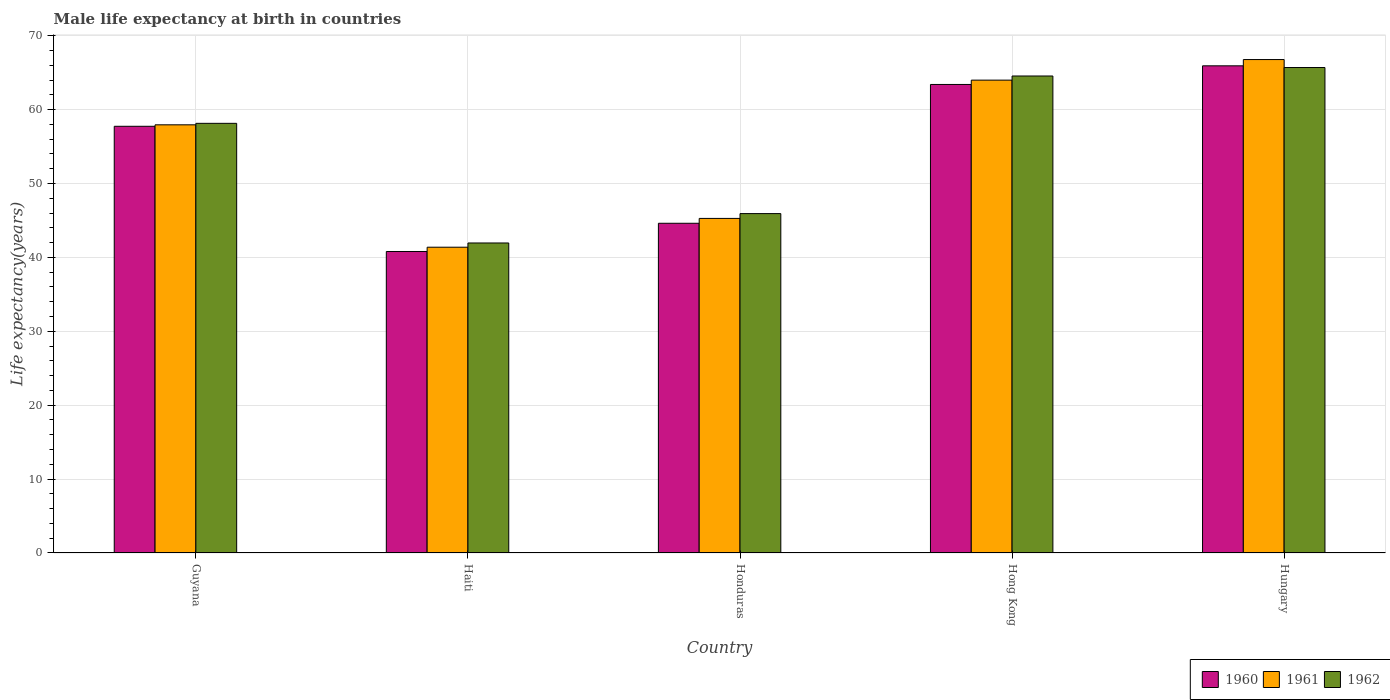How many groups of bars are there?
Your response must be concise. 5. Are the number of bars on each tick of the X-axis equal?
Offer a terse response. Yes. How many bars are there on the 5th tick from the left?
Provide a succinct answer. 3. What is the label of the 3rd group of bars from the left?
Ensure brevity in your answer.  Honduras. In how many cases, is the number of bars for a given country not equal to the number of legend labels?
Give a very brief answer. 0. What is the male life expectancy at birth in 1962 in Hong Kong?
Ensure brevity in your answer.  64.55. Across all countries, what is the maximum male life expectancy at birth in 1961?
Offer a very short reply. 66.78. Across all countries, what is the minimum male life expectancy at birth in 1961?
Your answer should be compact. 41.38. In which country was the male life expectancy at birth in 1960 maximum?
Keep it short and to the point. Hungary. In which country was the male life expectancy at birth in 1962 minimum?
Make the answer very short. Haiti. What is the total male life expectancy at birth in 1960 in the graph?
Offer a terse response. 272.51. What is the difference between the male life expectancy at birth in 1961 in Guyana and that in Haiti?
Give a very brief answer. 16.56. What is the difference between the male life expectancy at birth in 1960 in Hungary and the male life expectancy at birth in 1961 in Guyana?
Your answer should be compact. 7.98. What is the average male life expectancy at birth in 1960 per country?
Offer a very short reply. 54.5. What is the difference between the male life expectancy at birth of/in 1961 and male life expectancy at birth of/in 1960 in Hungary?
Provide a short and direct response. 0.85. In how many countries, is the male life expectancy at birth in 1961 greater than 38 years?
Your response must be concise. 5. What is the ratio of the male life expectancy at birth in 1962 in Guyana to that in Haiti?
Provide a short and direct response. 1.39. Is the male life expectancy at birth in 1962 in Guyana less than that in Hong Kong?
Keep it short and to the point. Yes. What is the difference between the highest and the second highest male life expectancy at birth in 1960?
Ensure brevity in your answer.  8.18. What is the difference between the highest and the lowest male life expectancy at birth in 1961?
Keep it short and to the point. 25.4. Is the sum of the male life expectancy at birth in 1960 in Haiti and Hong Kong greater than the maximum male life expectancy at birth in 1962 across all countries?
Offer a terse response. Yes. What does the 2nd bar from the left in Haiti represents?
Your answer should be very brief. 1961. What does the 1st bar from the right in Hong Kong represents?
Give a very brief answer. 1962. Is it the case that in every country, the sum of the male life expectancy at birth in 1961 and male life expectancy at birth in 1960 is greater than the male life expectancy at birth in 1962?
Offer a terse response. Yes. Are all the bars in the graph horizontal?
Provide a succinct answer. No. How many countries are there in the graph?
Provide a short and direct response. 5. What is the difference between two consecutive major ticks on the Y-axis?
Keep it short and to the point. 10. Are the values on the major ticks of Y-axis written in scientific E-notation?
Provide a succinct answer. No. How many legend labels are there?
Keep it short and to the point. 3. How are the legend labels stacked?
Keep it short and to the point. Horizontal. What is the title of the graph?
Make the answer very short. Male life expectancy at birth in countries. What is the label or title of the X-axis?
Provide a short and direct response. Country. What is the label or title of the Y-axis?
Ensure brevity in your answer.  Life expectancy(years). What is the Life expectancy(years) in 1960 in Guyana?
Ensure brevity in your answer.  57.75. What is the Life expectancy(years) of 1961 in Guyana?
Make the answer very short. 57.95. What is the Life expectancy(years) in 1962 in Guyana?
Give a very brief answer. 58.15. What is the Life expectancy(years) of 1960 in Haiti?
Offer a very short reply. 40.8. What is the Life expectancy(years) of 1961 in Haiti?
Give a very brief answer. 41.38. What is the Life expectancy(years) in 1962 in Haiti?
Your answer should be very brief. 41.96. What is the Life expectancy(years) of 1960 in Honduras?
Provide a short and direct response. 44.62. What is the Life expectancy(years) in 1961 in Honduras?
Your response must be concise. 45.28. What is the Life expectancy(years) in 1962 in Honduras?
Ensure brevity in your answer.  45.93. What is the Life expectancy(years) in 1960 in Hong Kong?
Your response must be concise. 63.41. What is the Life expectancy(years) in 1961 in Hong Kong?
Your answer should be very brief. 63.99. What is the Life expectancy(years) in 1962 in Hong Kong?
Ensure brevity in your answer.  64.55. What is the Life expectancy(years) in 1960 in Hungary?
Your answer should be compact. 65.93. What is the Life expectancy(years) of 1961 in Hungary?
Your response must be concise. 66.78. What is the Life expectancy(years) of 1962 in Hungary?
Your response must be concise. 65.7. Across all countries, what is the maximum Life expectancy(years) in 1960?
Give a very brief answer. 65.93. Across all countries, what is the maximum Life expectancy(years) of 1961?
Keep it short and to the point. 66.78. Across all countries, what is the maximum Life expectancy(years) of 1962?
Keep it short and to the point. 65.7. Across all countries, what is the minimum Life expectancy(years) of 1960?
Provide a short and direct response. 40.8. Across all countries, what is the minimum Life expectancy(years) in 1961?
Ensure brevity in your answer.  41.38. Across all countries, what is the minimum Life expectancy(years) in 1962?
Keep it short and to the point. 41.96. What is the total Life expectancy(years) in 1960 in the graph?
Offer a terse response. 272.51. What is the total Life expectancy(years) of 1961 in the graph?
Keep it short and to the point. 275.38. What is the total Life expectancy(years) in 1962 in the graph?
Make the answer very short. 276.29. What is the difference between the Life expectancy(years) in 1960 in Guyana and that in Haiti?
Provide a short and direct response. 16.94. What is the difference between the Life expectancy(years) of 1961 in Guyana and that in Haiti?
Your answer should be compact. 16.56. What is the difference between the Life expectancy(years) in 1962 in Guyana and that in Haiti?
Ensure brevity in your answer.  16.19. What is the difference between the Life expectancy(years) of 1960 in Guyana and that in Honduras?
Your answer should be very brief. 13.13. What is the difference between the Life expectancy(years) in 1961 in Guyana and that in Honduras?
Ensure brevity in your answer.  12.67. What is the difference between the Life expectancy(years) of 1962 in Guyana and that in Honduras?
Provide a succinct answer. 12.22. What is the difference between the Life expectancy(years) in 1960 in Guyana and that in Hong Kong?
Your answer should be very brief. -5.66. What is the difference between the Life expectancy(years) of 1961 in Guyana and that in Hong Kong?
Your answer should be very brief. -6.05. What is the difference between the Life expectancy(years) of 1962 in Guyana and that in Hong Kong?
Your answer should be compact. -6.41. What is the difference between the Life expectancy(years) of 1960 in Guyana and that in Hungary?
Make the answer very short. -8.18. What is the difference between the Life expectancy(years) of 1961 in Guyana and that in Hungary?
Keep it short and to the point. -8.83. What is the difference between the Life expectancy(years) of 1962 in Guyana and that in Hungary?
Ensure brevity in your answer.  -7.55. What is the difference between the Life expectancy(years) in 1960 in Haiti and that in Honduras?
Provide a succinct answer. -3.82. What is the difference between the Life expectancy(years) of 1961 in Haiti and that in Honduras?
Your response must be concise. -3.9. What is the difference between the Life expectancy(years) of 1962 in Haiti and that in Honduras?
Offer a terse response. -3.98. What is the difference between the Life expectancy(years) of 1960 in Haiti and that in Hong Kong?
Ensure brevity in your answer.  -22.6. What is the difference between the Life expectancy(years) of 1961 in Haiti and that in Hong Kong?
Give a very brief answer. -22.61. What is the difference between the Life expectancy(years) in 1962 in Haiti and that in Hong Kong?
Offer a terse response. -22.6. What is the difference between the Life expectancy(years) in 1960 in Haiti and that in Hungary?
Offer a terse response. -25.13. What is the difference between the Life expectancy(years) of 1961 in Haiti and that in Hungary?
Offer a very short reply. -25.4. What is the difference between the Life expectancy(years) of 1962 in Haiti and that in Hungary?
Provide a short and direct response. -23.74. What is the difference between the Life expectancy(years) of 1960 in Honduras and that in Hong Kong?
Your response must be concise. -18.79. What is the difference between the Life expectancy(years) in 1961 in Honduras and that in Hong Kong?
Offer a very short reply. -18.71. What is the difference between the Life expectancy(years) in 1962 in Honduras and that in Hong Kong?
Give a very brief answer. -18.62. What is the difference between the Life expectancy(years) of 1960 in Honduras and that in Hungary?
Give a very brief answer. -21.31. What is the difference between the Life expectancy(years) of 1961 in Honduras and that in Hungary?
Keep it short and to the point. -21.5. What is the difference between the Life expectancy(years) of 1962 in Honduras and that in Hungary?
Offer a very short reply. -19.77. What is the difference between the Life expectancy(years) in 1960 in Hong Kong and that in Hungary?
Offer a terse response. -2.52. What is the difference between the Life expectancy(years) in 1961 in Hong Kong and that in Hungary?
Your response must be concise. -2.79. What is the difference between the Life expectancy(years) of 1962 in Hong Kong and that in Hungary?
Make the answer very short. -1.15. What is the difference between the Life expectancy(years) of 1960 in Guyana and the Life expectancy(years) of 1961 in Haiti?
Your answer should be very brief. 16.37. What is the difference between the Life expectancy(years) in 1960 in Guyana and the Life expectancy(years) in 1962 in Haiti?
Ensure brevity in your answer.  15.79. What is the difference between the Life expectancy(years) of 1961 in Guyana and the Life expectancy(years) of 1962 in Haiti?
Make the answer very short. 15.99. What is the difference between the Life expectancy(years) of 1960 in Guyana and the Life expectancy(years) of 1961 in Honduras?
Give a very brief answer. 12.47. What is the difference between the Life expectancy(years) in 1960 in Guyana and the Life expectancy(years) in 1962 in Honduras?
Keep it short and to the point. 11.82. What is the difference between the Life expectancy(years) in 1961 in Guyana and the Life expectancy(years) in 1962 in Honduras?
Provide a short and direct response. 12.02. What is the difference between the Life expectancy(years) of 1960 in Guyana and the Life expectancy(years) of 1961 in Hong Kong?
Make the answer very short. -6.25. What is the difference between the Life expectancy(years) in 1960 in Guyana and the Life expectancy(years) in 1962 in Hong Kong?
Ensure brevity in your answer.  -6.81. What is the difference between the Life expectancy(years) of 1961 in Guyana and the Life expectancy(years) of 1962 in Hong Kong?
Provide a short and direct response. -6.61. What is the difference between the Life expectancy(years) in 1960 in Guyana and the Life expectancy(years) in 1961 in Hungary?
Keep it short and to the point. -9.03. What is the difference between the Life expectancy(years) in 1960 in Guyana and the Life expectancy(years) in 1962 in Hungary?
Provide a short and direct response. -7.95. What is the difference between the Life expectancy(years) in 1961 in Guyana and the Life expectancy(years) in 1962 in Hungary?
Make the answer very short. -7.75. What is the difference between the Life expectancy(years) of 1960 in Haiti and the Life expectancy(years) of 1961 in Honduras?
Give a very brief answer. -4.47. What is the difference between the Life expectancy(years) in 1960 in Haiti and the Life expectancy(years) in 1962 in Honduras?
Ensure brevity in your answer.  -5.13. What is the difference between the Life expectancy(years) of 1961 in Haiti and the Life expectancy(years) of 1962 in Honduras?
Offer a very short reply. -4.55. What is the difference between the Life expectancy(years) in 1960 in Haiti and the Life expectancy(years) in 1961 in Hong Kong?
Your answer should be compact. -23.19. What is the difference between the Life expectancy(years) in 1960 in Haiti and the Life expectancy(years) in 1962 in Hong Kong?
Make the answer very short. -23.75. What is the difference between the Life expectancy(years) in 1961 in Haiti and the Life expectancy(years) in 1962 in Hong Kong?
Make the answer very short. -23.17. What is the difference between the Life expectancy(years) in 1960 in Haiti and the Life expectancy(years) in 1961 in Hungary?
Provide a short and direct response. -25.98. What is the difference between the Life expectancy(years) of 1960 in Haiti and the Life expectancy(years) of 1962 in Hungary?
Give a very brief answer. -24.9. What is the difference between the Life expectancy(years) of 1961 in Haiti and the Life expectancy(years) of 1962 in Hungary?
Offer a very short reply. -24.32. What is the difference between the Life expectancy(years) of 1960 in Honduras and the Life expectancy(years) of 1961 in Hong Kong?
Keep it short and to the point. -19.37. What is the difference between the Life expectancy(years) of 1960 in Honduras and the Life expectancy(years) of 1962 in Hong Kong?
Offer a very short reply. -19.93. What is the difference between the Life expectancy(years) in 1961 in Honduras and the Life expectancy(years) in 1962 in Hong Kong?
Keep it short and to the point. -19.27. What is the difference between the Life expectancy(years) in 1960 in Honduras and the Life expectancy(years) in 1961 in Hungary?
Make the answer very short. -22.16. What is the difference between the Life expectancy(years) of 1960 in Honduras and the Life expectancy(years) of 1962 in Hungary?
Ensure brevity in your answer.  -21.08. What is the difference between the Life expectancy(years) in 1961 in Honduras and the Life expectancy(years) in 1962 in Hungary?
Offer a terse response. -20.42. What is the difference between the Life expectancy(years) of 1960 in Hong Kong and the Life expectancy(years) of 1961 in Hungary?
Your answer should be compact. -3.37. What is the difference between the Life expectancy(years) in 1960 in Hong Kong and the Life expectancy(years) in 1962 in Hungary?
Your answer should be compact. -2.29. What is the difference between the Life expectancy(years) of 1961 in Hong Kong and the Life expectancy(years) of 1962 in Hungary?
Give a very brief answer. -1.71. What is the average Life expectancy(years) in 1960 per country?
Keep it short and to the point. 54.5. What is the average Life expectancy(years) of 1961 per country?
Provide a short and direct response. 55.08. What is the average Life expectancy(years) of 1962 per country?
Provide a short and direct response. 55.26. What is the difference between the Life expectancy(years) in 1960 and Life expectancy(years) in 1961 in Guyana?
Provide a short and direct response. -0.2. What is the difference between the Life expectancy(years) of 1960 and Life expectancy(years) of 1962 in Guyana?
Keep it short and to the point. -0.4. What is the difference between the Life expectancy(years) in 1961 and Life expectancy(years) in 1962 in Guyana?
Provide a short and direct response. -0.2. What is the difference between the Life expectancy(years) of 1960 and Life expectancy(years) of 1961 in Haiti?
Ensure brevity in your answer.  -0.58. What is the difference between the Life expectancy(years) in 1960 and Life expectancy(years) in 1962 in Haiti?
Make the answer very short. -1.15. What is the difference between the Life expectancy(years) in 1961 and Life expectancy(years) in 1962 in Haiti?
Provide a short and direct response. -0.57. What is the difference between the Life expectancy(years) in 1960 and Life expectancy(years) in 1961 in Honduras?
Provide a short and direct response. -0.66. What is the difference between the Life expectancy(years) of 1960 and Life expectancy(years) of 1962 in Honduras?
Make the answer very short. -1.31. What is the difference between the Life expectancy(years) of 1961 and Life expectancy(years) of 1962 in Honduras?
Offer a very short reply. -0.65. What is the difference between the Life expectancy(years) in 1960 and Life expectancy(years) in 1961 in Hong Kong?
Give a very brief answer. -0.59. What is the difference between the Life expectancy(years) in 1960 and Life expectancy(years) in 1962 in Hong Kong?
Offer a terse response. -1.15. What is the difference between the Life expectancy(years) of 1961 and Life expectancy(years) of 1962 in Hong Kong?
Your response must be concise. -0.56. What is the difference between the Life expectancy(years) in 1960 and Life expectancy(years) in 1961 in Hungary?
Your answer should be very brief. -0.85. What is the difference between the Life expectancy(years) of 1960 and Life expectancy(years) of 1962 in Hungary?
Keep it short and to the point. 0.23. What is the ratio of the Life expectancy(years) of 1960 in Guyana to that in Haiti?
Ensure brevity in your answer.  1.42. What is the ratio of the Life expectancy(years) in 1961 in Guyana to that in Haiti?
Your answer should be compact. 1.4. What is the ratio of the Life expectancy(years) in 1962 in Guyana to that in Haiti?
Ensure brevity in your answer.  1.39. What is the ratio of the Life expectancy(years) of 1960 in Guyana to that in Honduras?
Provide a succinct answer. 1.29. What is the ratio of the Life expectancy(years) of 1961 in Guyana to that in Honduras?
Offer a very short reply. 1.28. What is the ratio of the Life expectancy(years) in 1962 in Guyana to that in Honduras?
Keep it short and to the point. 1.27. What is the ratio of the Life expectancy(years) in 1960 in Guyana to that in Hong Kong?
Keep it short and to the point. 0.91. What is the ratio of the Life expectancy(years) of 1961 in Guyana to that in Hong Kong?
Offer a very short reply. 0.91. What is the ratio of the Life expectancy(years) in 1962 in Guyana to that in Hong Kong?
Your response must be concise. 0.9. What is the ratio of the Life expectancy(years) of 1960 in Guyana to that in Hungary?
Give a very brief answer. 0.88. What is the ratio of the Life expectancy(years) of 1961 in Guyana to that in Hungary?
Make the answer very short. 0.87. What is the ratio of the Life expectancy(years) of 1962 in Guyana to that in Hungary?
Your answer should be very brief. 0.89. What is the ratio of the Life expectancy(years) in 1960 in Haiti to that in Honduras?
Ensure brevity in your answer.  0.91. What is the ratio of the Life expectancy(years) of 1961 in Haiti to that in Honduras?
Your answer should be very brief. 0.91. What is the ratio of the Life expectancy(years) in 1962 in Haiti to that in Honduras?
Keep it short and to the point. 0.91. What is the ratio of the Life expectancy(years) in 1960 in Haiti to that in Hong Kong?
Keep it short and to the point. 0.64. What is the ratio of the Life expectancy(years) of 1961 in Haiti to that in Hong Kong?
Give a very brief answer. 0.65. What is the ratio of the Life expectancy(years) in 1962 in Haiti to that in Hong Kong?
Your answer should be very brief. 0.65. What is the ratio of the Life expectancy(years) in 1960 in Haiti to that in Hungary?
Offer a very short reply. 0.62. What is the ratio of the Life expectancy(years) in 1961 in Haiti to that in Hungary?
Offer a terse response. 0.62. What is the ratio of the Life expectancy(years) of 1962 in Haiti to that in Hungary?
Ensure brevity in your answer.  0.64. What is the ratio of the Life expectancy(years) in 1960 in Honduras to that in Hong Kong?
Offer a terse response. 0.7. What is the ratio of the Life expectancy(years) of 1961 in Honduras to that in Hong Kong?
Provide a succinct answer. 0.71. What is the ratio of the Life expectancy(years) of 1962 in Honduras to that in Hong Kong?
Offer a terse response. 0.71. What is the ratio of the Life expectancy(years) in 1960 in Honduras to that in Hungary?
Offer a very short reply. 0.68. What is the ratio of the Life expectancy(years) in 1961 in Honduras to that in Hungary?
Offer a terse response. 0.68. What is the ratio of the Life expectancy(years) of 1962 in Honduras to that in Hungary?
Your answer should be compact. 0.7. What is the ratio of the Life expectancy(years) in 1960 in Hong Kong to that in Hungary?
Your answer should be very brief. 0.96. What is the ratio of the Life expectancy(years) of 1962 in Hong Kong to that in Hungary?
Make the answer very short. 0.98. What is the difference between the highest and the second highest Life expectancy(years) of 1960?
Offer a very short reply. 2.52. What is the difference between the highest and the second highest Life expectancy(years) in 1961?
Offer a very short reply. 2.79. What is the difference between the highest and the second highest Life expectancy(years) of 1962?
Make the answer very short. 1.15. What is the difference between the highest and the lowest Life expectancy(years) in 1960?
Your answer should be compact. 25.13. What is the difference between the highest and the lowest Life expectancy(years) of 1961?
Ensure brevity in your answer.  25.4. What is the difference between the highest and the lowest Life expectancy(years) in 1962?
Provide a short and direct response. 23.74. 